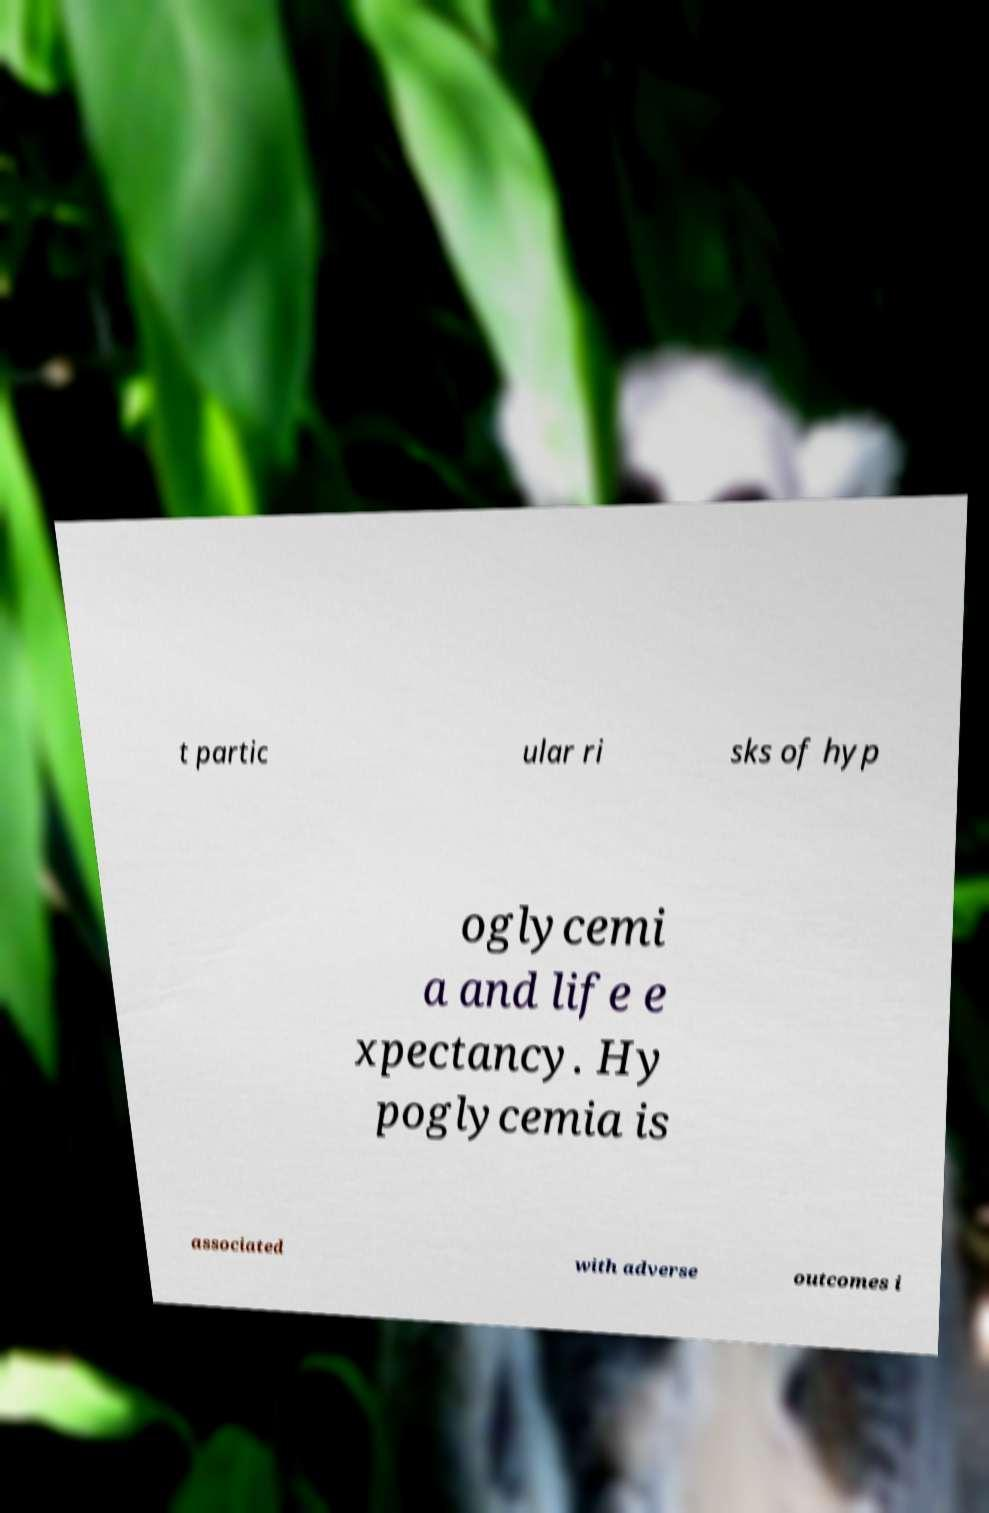There's text embedded in this image that I need extracted. Can you transcribe it verbatim? t partic ular ri sks of hyp oglycemi a and life e xpectancy. Hy poglycemia is associated with adverse outcomes i 